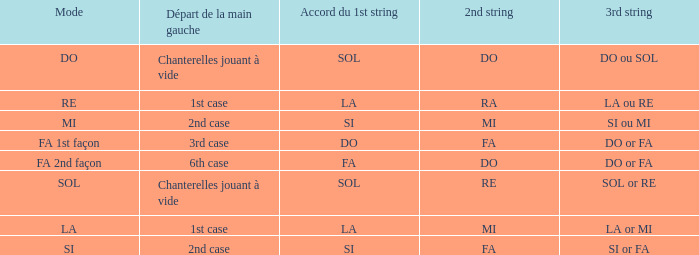For the 2nd string of do and an accord du 1st string of fa, what is the left hand start? 6th case. 